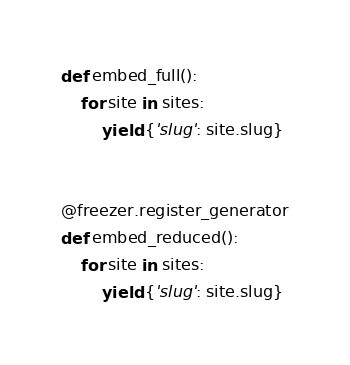<code> <loc_0><loc_0><loc_500><loc_500><_Python_>def embed_full():
    for site in sites:
        yield {'slug': site.slug}
        
        
@freezer.register_generator
def embed_reduced():
    for site in sites:
        yield {'slug': site.slug}
</code> 